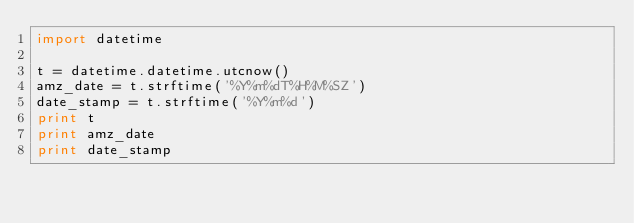Convert code to text. <code><loc_0><loc_0><loc_500><loc_500><_Python_>import datetime

t = datetime.datetime.utcnow()
amz_date = t.strftime('%Y%m%dT%H%M%SZ')
date_stamp = t.strftime('%Y%m%d')
print t
print amz_date
print date_stamp
</code> 